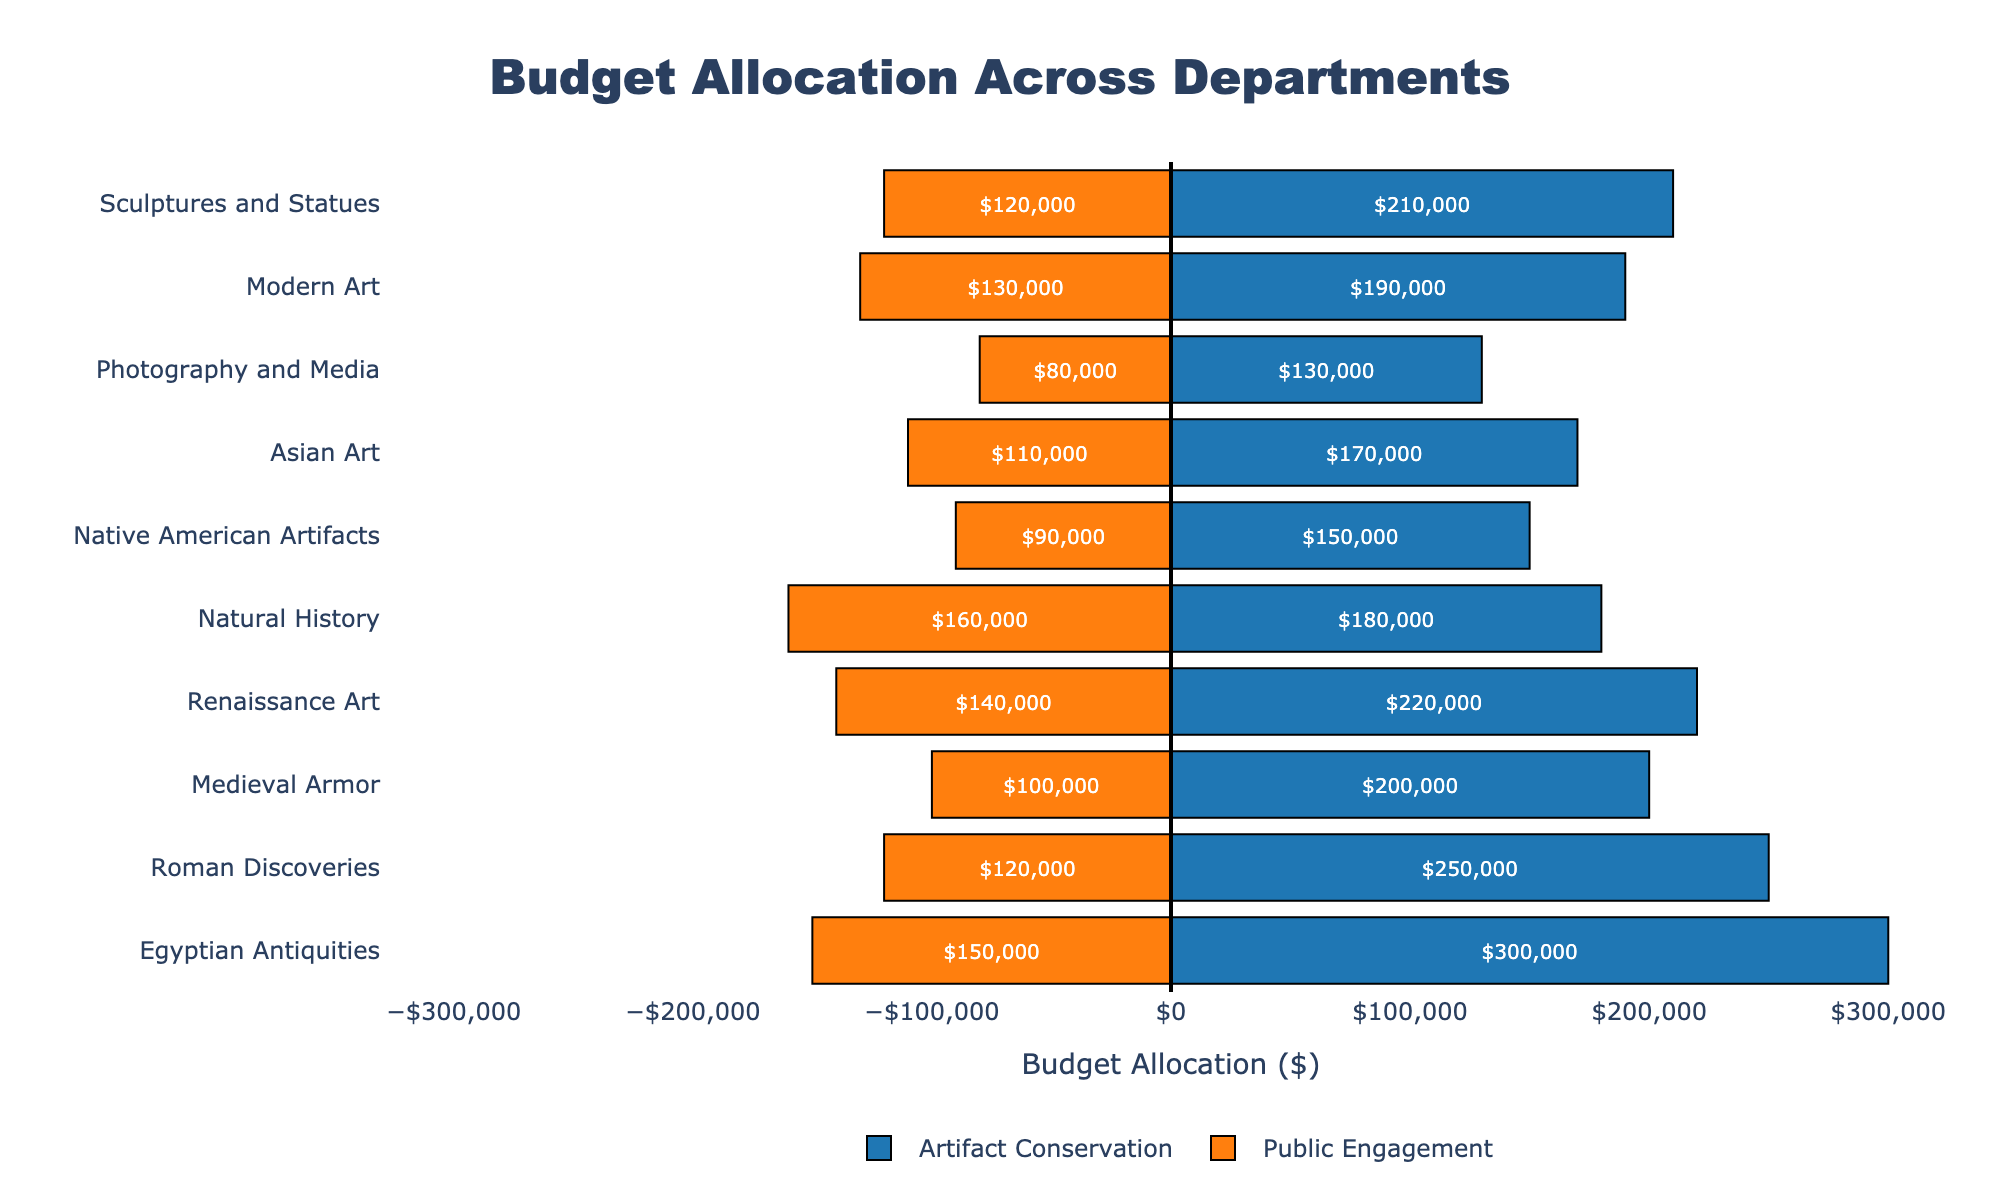What's the total budget allocation for the Medieval Armor department? The budget allocation consists of Artifact Conservation and Public Engagement. For Medieval Armor, the artifact conservation budget is $200,000, and the public engagement budget is $100,000. Adding these together: $200,000 + $100,000 = $300,000
Answer: $300,000 Which department has the highest budget for Public Engagement? Looking at the figure, the department with the longest orange bar (representing Public Engagement) has the highest budget. The Natural History department has the highest budget for Public Engagement with $160,000.
Answer: Natural History Compare the total budget of the Native American Artifacts department to that of the Photography and Media department. Which one is higher, and by how much? The total budget for Native American Artifacts is $150,000 (Artifact Conservation) + $90,000 (Public Engagement) = $240,000. For Photography and Media, it is $130,000 (Artifact Conservation) + $80,000 (Public Engagement) = $210,000. Native American Artifacts has a higher budget by $240,000 - $210,000 = $30,000.
Answer: Native American Artifacts by $30,000 What's the average budget allocation for Public Engagement across all departments? Summing all the Public Engagement budgets: $150,000 + $120,000 + $100,000 + $140,000 + $160,000 + $90,000 + $110,000 + $80,000 + $130,000 + $120,000 = $1,200,000. There are 10 departments, so the average is $1,200,000 / 10 = $120,000.
Answer: $120,000 How much more does the Egyptian Antiquities department spend on Artifact Conservation compared to public engagement? The Egyptian Antiquities department spends $300,000 on Artifact Conservation and $150,000 on Public Engagement. So the difference is $300,000 - $150,000 = $150,000.
Answer: $150,000 Which department allocates a higher percentage of its total budget to Public Engagement: Asian Art or Modern Art? For Asian Art, the total budget is $170,000 (Artifact Conservation) + $110,000 (Public Engagement) = $280,000, and the percentage for Public Engagement is ($110,000 / $280,000) * 100 ≈ 39.29%. For Modern Art, the total budget is $190,000 + $130,000 = $320,000, and the percentage is ($130,000 / $320,000) * 100 ≈ 40.63%. Modern Art allocates a higher percentage.
Answer: Modern Art Between Roman Discoveries and Sculptures and Statues, which department has a higher total budget, and what percentage of its budget is allocated to Artifact Conservation? For Roman Discoveries, the total budget is $250,000 (Artifact Conservation) + $120,000 (Public Engagement) = $370,000. The percentage allocation to Artifact Conservation is ($250,000 / $370,000) * 100 ≈ 67.57%. For Sculptures and Statues, the total budget is $210,000 + $120,000 = $330,000, with a percentage allocation to Artifact Conservation of ($210,000 / $330,000) * 100 ≈ 63.64%. Roman Discoveries has a higher total budget, and its percentage allocation to Artifact Conservation is slightly higher.
Answer: Roman Discoveries with approx. 67.57% for Artifact Conservation What is the combined budget for Artifact Conservation for the Natural History and Modern Art departments? Adding the Artifact Conservation budgets of Natural History ($180,000) and Modern Art ($190,000) results in $180,000 + $190,000 = $370,000.
Answer: $370,000 